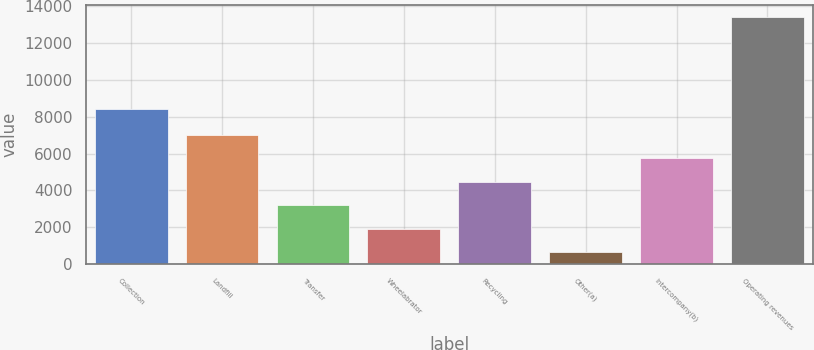Convert chart to OTSL. <chart><loc_0><loc_0><loc_500><loc_500><bar_chart><fcel>Collection<fcel>Landfill<fcel>Transfer<fcel>Wheelabrator<fcel>Recycling<fcel>Other(a)<fcel>Intercompany(b)<fcel>Operating revenues<nl><fcel>8406<fcel>7016.5<fcel>3199.6<fcel>1927.3<fcel>4471.9<fcel>655<fcel>5744.2<fcel>13378<nl></chart> 